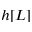Convert formula to latex. <formula><loc_0><loc_0><loc_500><loc_500>h [ L ]</formula> 